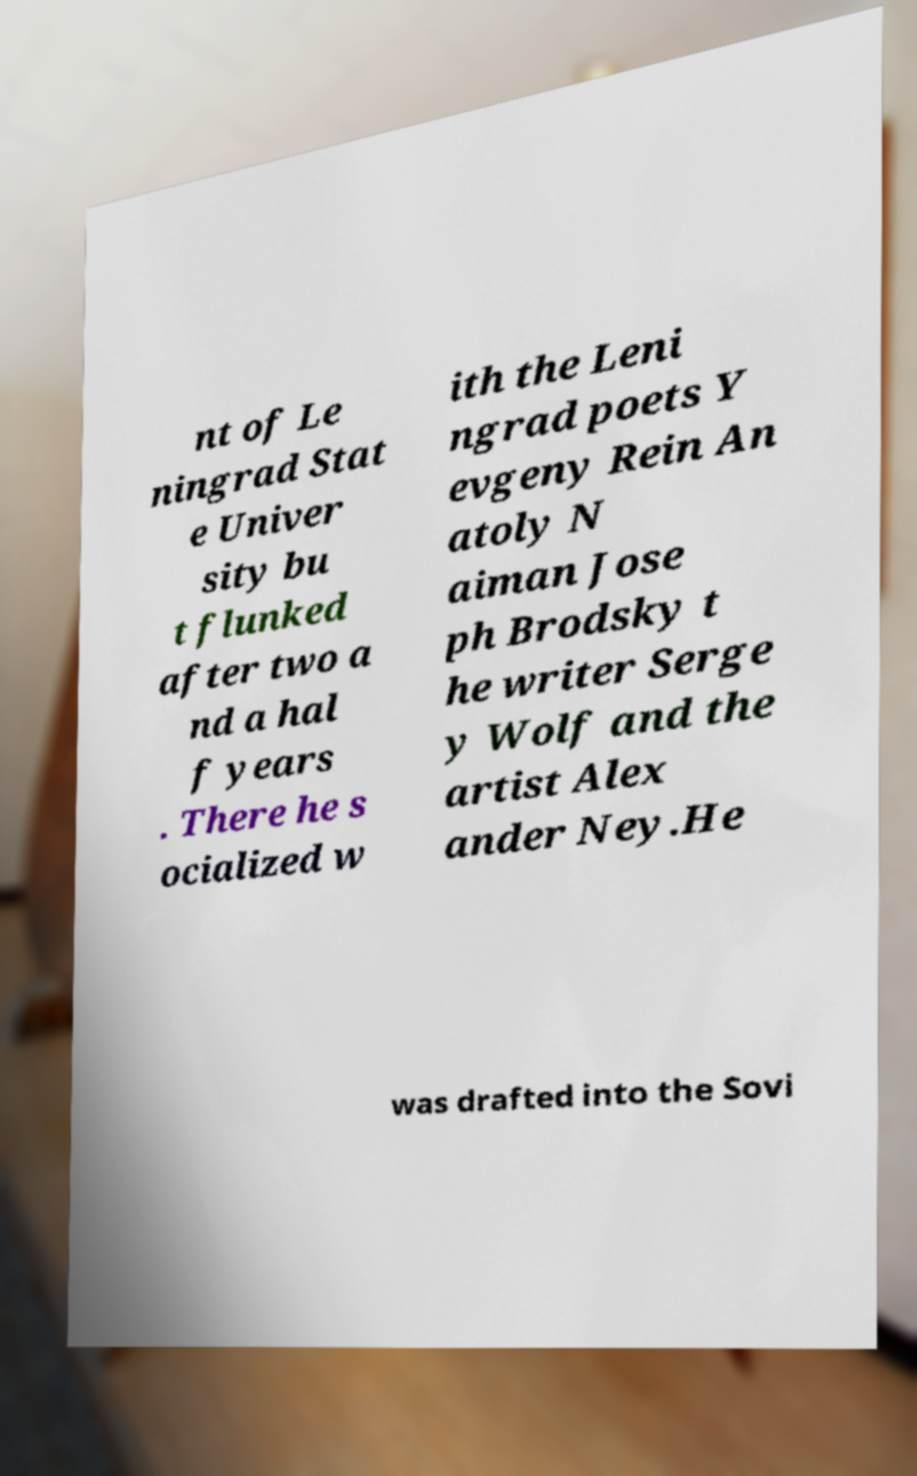Please read and relay the text visible in this image. What does it say? nt of Le ningrad Stat e Univer sity bu t flunked after two a nd a hal f years . There he s ocialized w ith the Leni ngrad poets Y evgeny Rein An atoly N aiman Jose ph Brodsky t he writer Serge y Wolf and the artist Alex ander Ney.He was drafted into the Sovi 